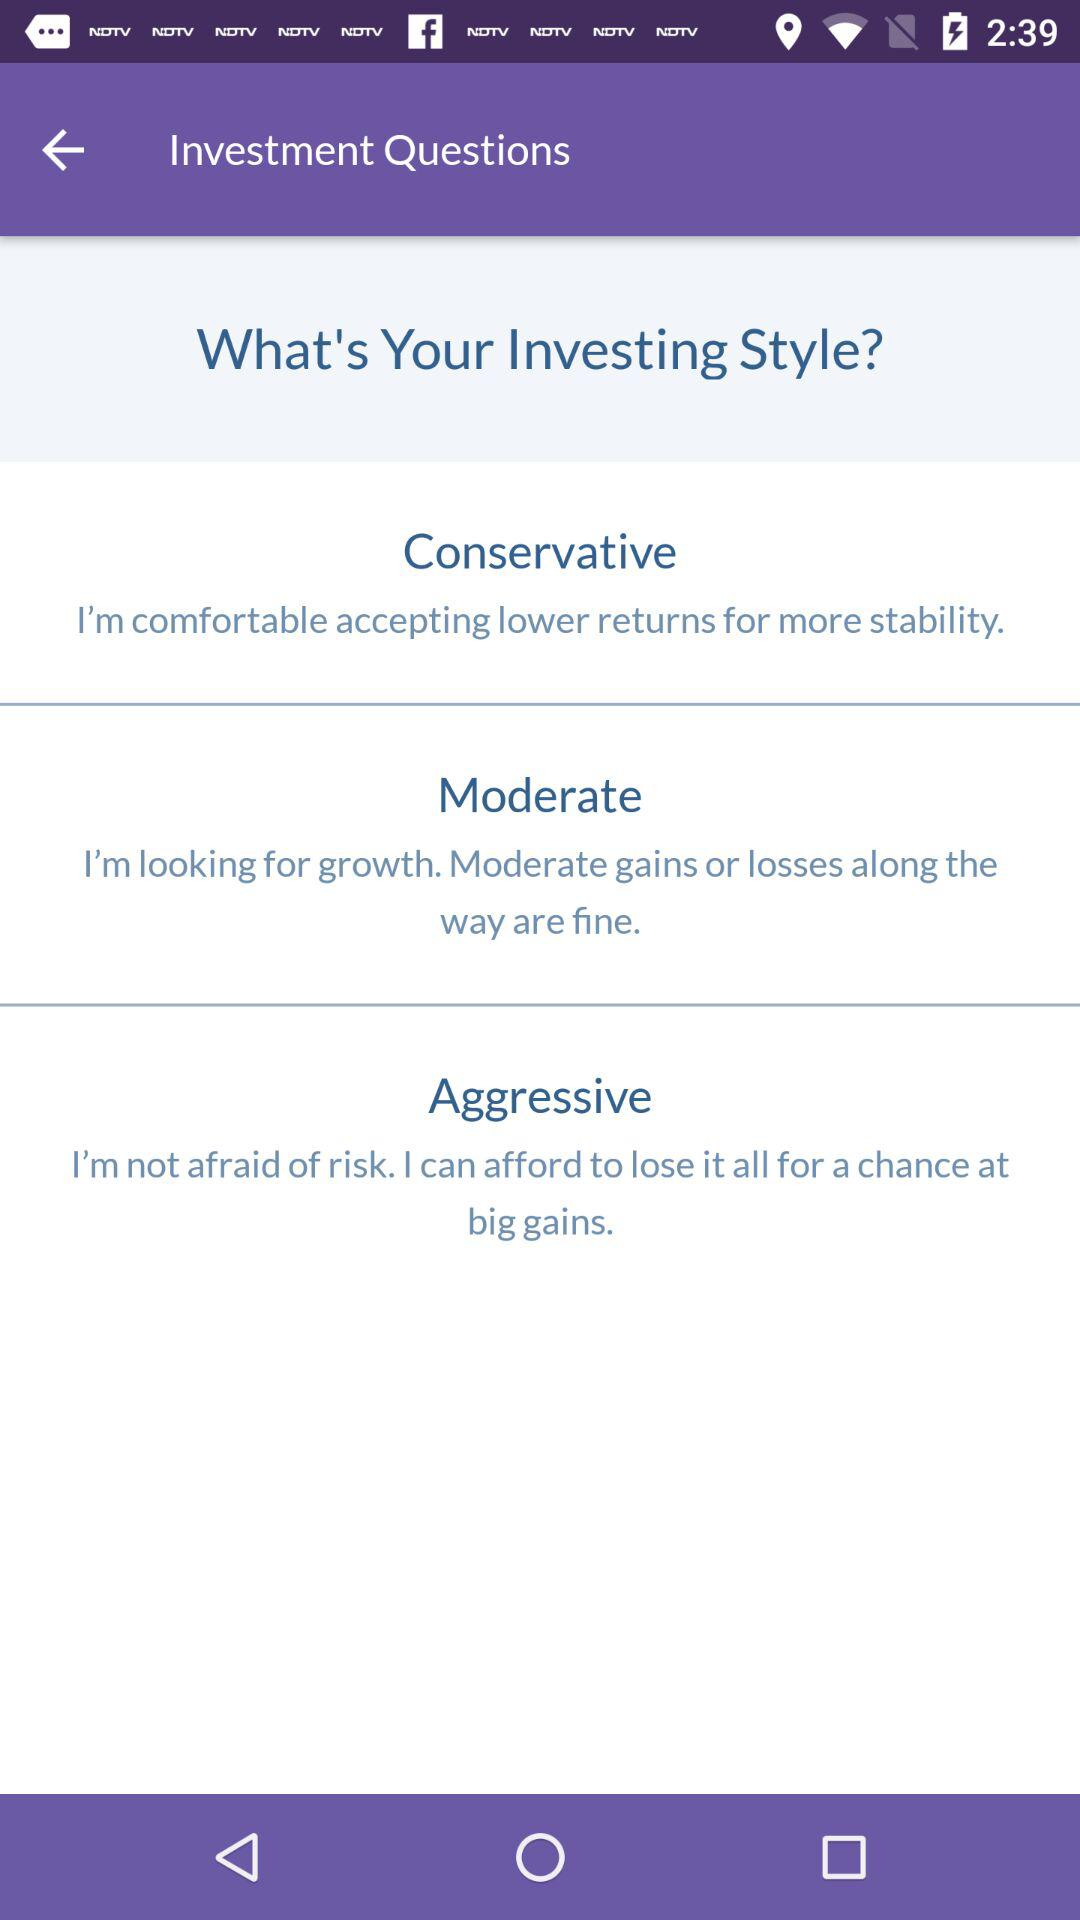How many investment styles are there?
Answer the question using a single word or phrase. 3 